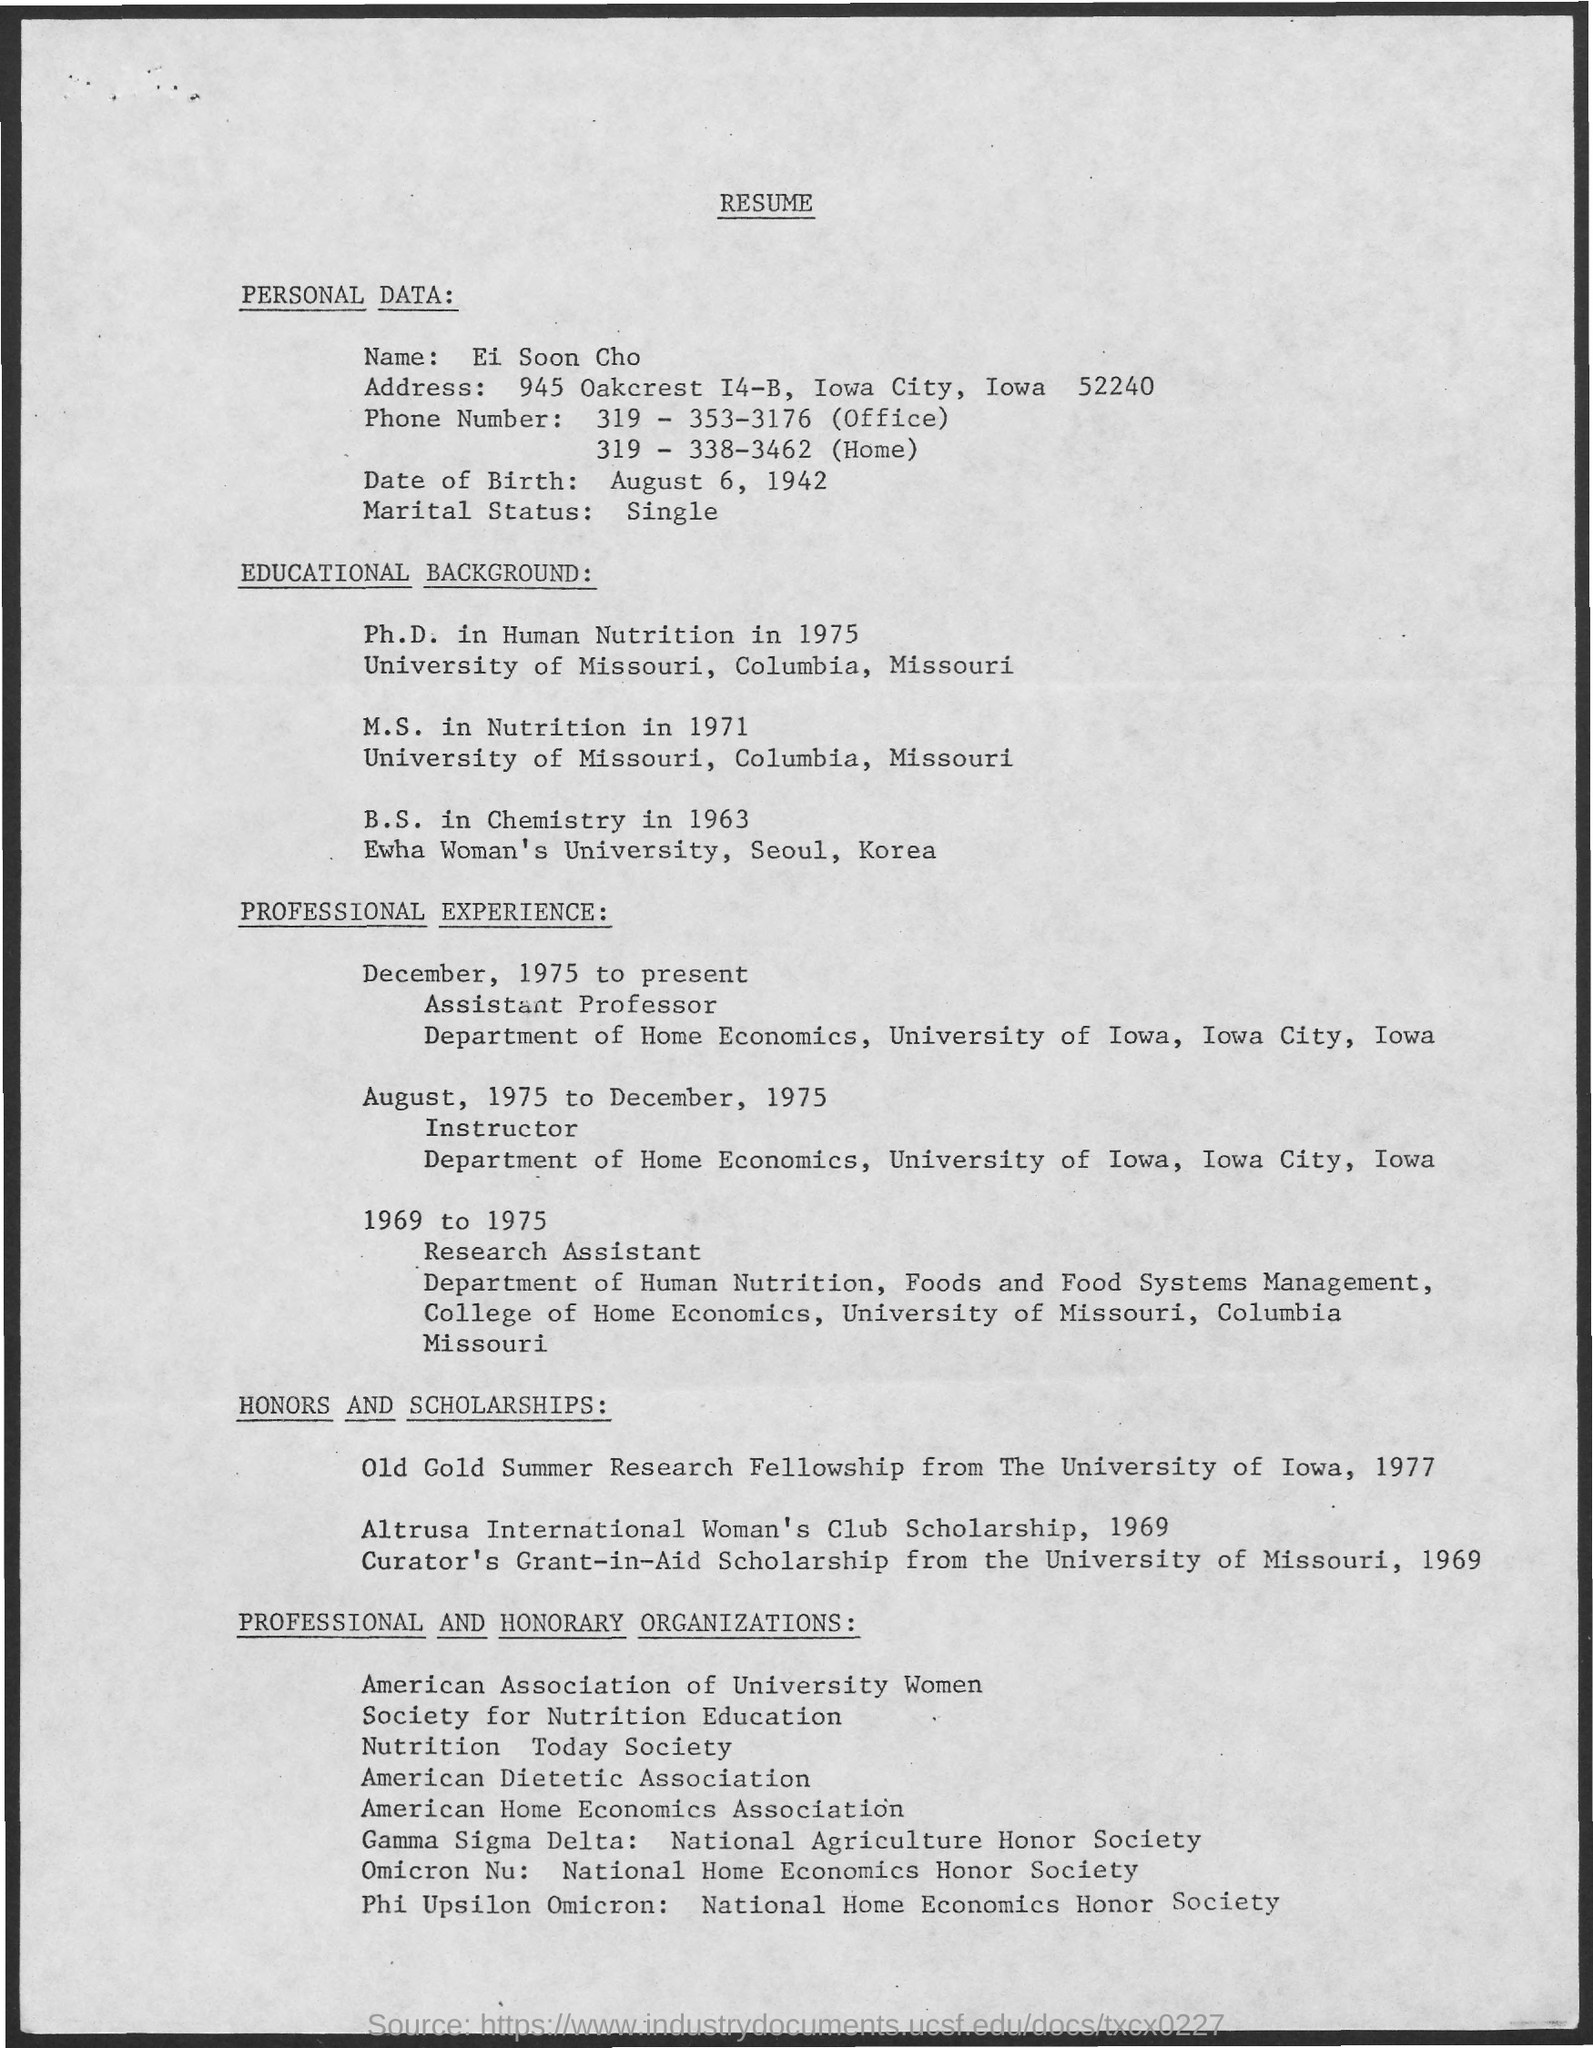List a handful of essential elements in this visual. The individual's marital status, as indicated in their resume, is "single. The person who wrote this resume is Ei Soon Cho. The date of birth mentioned in the resume is August 6, 1942. 